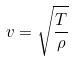Convert formula to latex. <formula><loc_0><loc_0><loc_500><loc_500>v = \sqrt { \frac { T } { \rho } }</formula> 